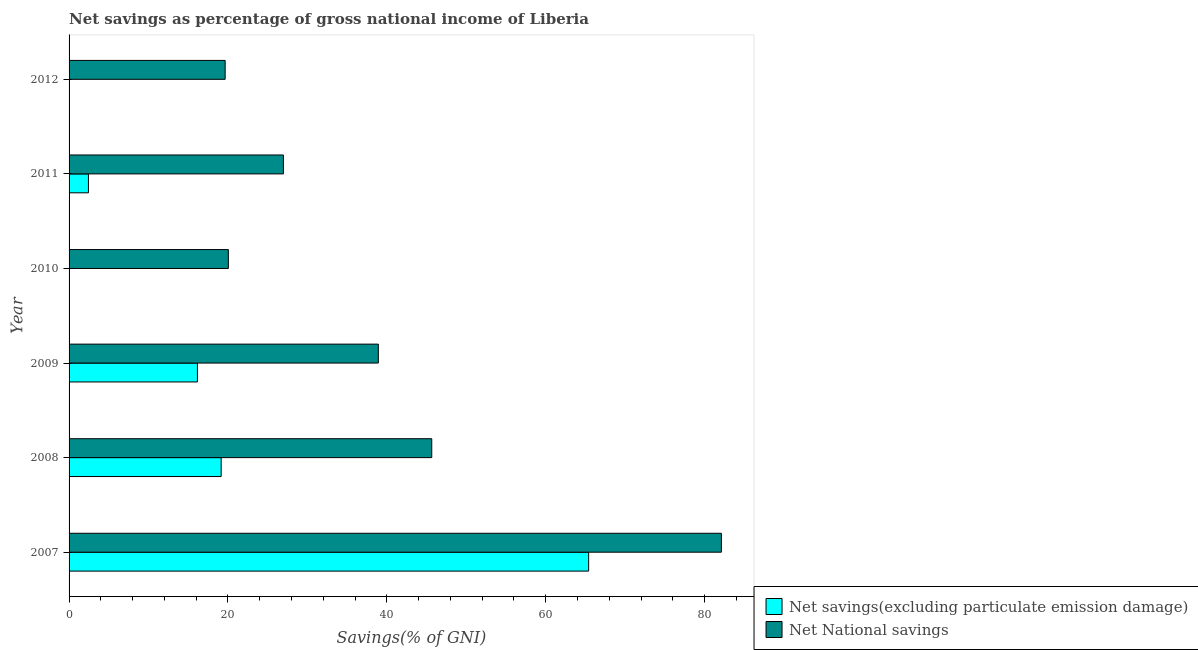Are the number of bars per tick equal to the number of legend labels?
Offer a terse response. No. Are the number of bars on each tick of the Y-axis equal?
Offer a very short reply. No. What is the label of the 2nd group of bars from the top?
Offer a terse response. 2011. What is the net national savings in 2010?
Ensure brevity in your answer.  20.05. Across all years, what is the maximum net national savings?
Your answer should be compact. 82.12. In which year was the net national savings maximum?
Ensure brevity in your answer.  2007. What is the total net national savings in the graph?
Your answer should be compact. 233.39. What is the difference between the net national savings in 2008 and that in 2009?
Your answer should be compact. 6.73. What is the difference between the net national savings in 2012 and the net savings(excluding particulate emission damage) in 2008?
Keep it short and to the point. 0.5. What is the average net savings(excluding particulate emission damage) per year?
Give a very brief answer. 17.19. In the year 2008, what is the difference between the net national savings and net savings(excluding particulate emission damage)?
Your answer should be compact. 26.51. What is the ratio of the net national savings in 2007 to that in 2010?
Your answer should be compact. 4.1. Is the net national savings in 2011 less than that in 2012?
Offer a very short reply. No. What is the difference between the highest and the second highest net national savings?
Keep it short and to the point. 36.46. What is the difference between the highest and the lowest net national savings?
Your answer should be compact. 62.47. Is the sum of the net savings(excluding particulate emission damage) in 2008 and 2011 greater than the maximum net national savings across all years?
Ensure brevity in your answer.  No. Are all the bars in the graph horizontal?
Give a very brief answer. Yes. How many years are there in the graph?
Ensure brevity in your answer.  6. Does the graph contain grids?
Your answer should be compact. No. Where does the legend appear in the graph?
Offer a terse response. Bottom right. What is the title of the graph?
Ensure brevity in your answer.  Net savings as percentage of gross national income of Liberia. Does "Arms exports" appear as one of the legend labels in the graph?
Provide a short and direct response. No. What is the label or title of the X-axis?
Offer a terse response. Savings(% of GNI). What is the Savings(% of GNI) in Net savings(excluding particulate emission damage) in 2007?
Your answer should be very brief. 65.41. What is the Savings(% of GNI) in Net National savings in 2007?
Your answer should be very brief. 82.12. What is the Savings(% of GNI) of Net savings(excluding particulate emission damage) in 2008?
Keep it short and to the point. 19.15. What is the Savings(% of GNI) in Net National savings in 2008?
Keep it short and to the point. 45.66. What is the Savings(% of GNI) in Net savings(excluding particulate emission damage) in 2009?
Your answer should be compact. 16.16. What is the Savings(% of GNI) of Net National savings in 2009?
Offer a very short reply. 38.93. What is the Savings(% of GNI) in Net savings(excluding particulate emission damage) in 2010?
Offer a terse response. 0. What is the Savings(% of GNI) in Net National savings in 2010?
Your answer should be compact. 20.05. What is the Savings(% of GNI) in Net savings(excluding particulate emission damage) in 2011?
Offer a very short reply. 2.44. What is the Savings(% of GNI) in Net National savings in 2011?
Give a very brief answer. 26.98. What is the Savings(% of GNI) of Net savings(excluding particulate emission damage) in 2012?
Offer a terse response. 0. What is the Savings(% of GNI) in Net National savings in 2012?
Ensure brevity in your answer.  19.65. Across all years, what is the maximum Savings(% of GNI) in Net savings(excluding particulate emission damage)?
Offer a very short reply. 65.41. Across all years, what is the maximum Savings(% of GNI) in Net National savings?
Offer a terse response. 82.12. Across all years, what is the minimum Savings(% of GNI) in Net National savings?
Ensure brevity in your answer.  19.65. What is the total Savings(% of GNI) in Net savings(excluding particulate emission damage) in the graph?
Your response must be concise. 103.15. What is the total Savings(% of GNI) of Net National savings in the graph?
Offer a very short reply. 233.39. What is the difference between the Savings(% of GNI) of Net savings(excluding particulate emission damage) in 2007 and that in 2008?
Your answer should be compact. 46.26. What is the difference between the Savings(% of GNI) of Net National savings in 2007 and that in 2008?
Provide a short and direct response. 36.46. What is the difference between the Savings(% of GNI) of Net savings(excluding particulate emission damage) in 2007 and that in 2009?
Provide a succinct answer. 49.25. What is the difference between the Savings(% of GNI) in Net National savings in 2007 and that in 2009?
Your response must be concise. 43.19. What is the difference between the Savings(% of GNI) of Net National savings in 2007 and that in 2010?
Your answer should be very brief. 62.07. What is the difference between the Savings(% of GNI) of Net savings(excluding particulate emission damage) in 2007 and that in 2011?
Provide a succinct answer. 62.97. What is the difference between the Savings(% of GNI) in Net National savings in 2007 and that in 2011?
Your answer should be very brief. 55.14. What is the difference between the Savings(% of GNI) in Net National savings in 2007 and that in 2012?
Provide a short and direct response. 62.47. What is the difference between the Savings(% of GNI) of Net savings(excluding particulate emission damage) in 2008 and that in 2009?
Give a very brief answer. 2.99. What is the difference between the Savings(% of GNI) of Net National savings in 2008 and that in 2009?
Offer a very short reply. 6.73. What is the difference between the Savings(% of GNI) in Net National savings in 2008 and that in 2010?
Offer a very short reply. 25.61. What is the difference between the Savings(% of GNI) of Net savings(excluding particulate emission damage) in 2008 and that in 2011?
Offer a very short reply. 16.71. What is the difference between the Savings(% of GNI) in Net National savings in 2008 and that in 2011?
Offer a very short reply. 18.68. What is the difference between the Savings(% of GNI) in Net National savings in 2008 and that in 2012?
Provide a succinct answer. 26.01. What is the difference between the Savings(% of GNI) in Net National savings in 2009 and that in 2010?
Your answer should be very brief. 18.88. What is the difference between the Savings(% of GNI) in Net savings(excluding particulate emission damage) in 2009 and that in 2011?
Your answer should be compact. 13.72. What is the difference between the Savings(% of GNI) of Net National savings in 2009 and that in 2011?
Provide a short and direct response. 11.95. What is the difference between the Savings(% of GNI) of Net National savings in 2009 and that in 2012?
Give a very brief answer. 19.28. What is the difference between the Savings(% of GNI) in Net National savings in 2010 and that in 2011?
Provide a succinct answer. -6.93. What is the difference between the Savings(% of GNI) of Net National savings in 2010 and that in 2012?
Your response must be concise. 0.4. What is the difference between the Savings(% of GNI) of Net National savings in 2011 and that in 2012?
Keep it short and to the point. 7.33. What is the difference between the Savings(% of GNI) of Net savings(excluding particulate emission damage) in 2007 and the Savings(% of GNI) of Net National savings in 2008?
Your answer should be very brief. 19.75. What is the difference between the Savings(% of GNI) of Net savings(excluding particulate emission damage) in 2007 and the Savings(% of GNI) of Net National savings in 2009?
Keep it short and to the point. 26.48. What is the difference between the Savings(% of GNI) in Net savings(excluding particulate emission damage) in 2007 and the Savings(% of GNI) in Net National savings in 2010?
Provide a short and direct response. 45.36. What is the difference between the Savings(% of GNI) in Net savings(excluding particulate emission damage) in 2007 and the Savings(% of GNI) in Net National savings in 2011?
Ensure brevity in your answer.  38.43. What is the difference between the Savings(% of GNI) of Net savings(excluding particulate emission damage) in 2007 and the Savings(% of GNI) of Net National savings in 2012?
Keep it short and to the point. 45.76. What is the difference between the Savings(% of GNI) in Net savings(excluding particulate emission damage) in 2008 and the Savings(% of GNI) in Net National savings in 2009?
Provide a succinct answer. -19.79. What is the difference between the Savings(% of GNI) in Net savings(excluding particulate emission damage) in 2008 and the Savings(% of GNI) in Net National savings in 2010?
Provide a succinct answer. -0.9. What is the difference between the Savings(% of GNI) in Net savings(excluding particulate emission damage) in 2008 and the Savings(% of GNI) in Net National savings in 2011?
Keep it short and to the point. -7.83. What is the difference between the Savings(% of GNI) of Net savings(excluding particulate emission damage) in 2008 and the Savings(% of GNI) of Net National savings in 2012?
Provide a short and direct response. -0.5. What is the difference between the Savings(% of GNI) in Net savings(excluding particulate emission damage) in 2009 and the Savings(% of GNI) in Net National savings in 2010?
Offer a terse response. -3.89. What is the difference between the Savings(% of GNI) in Net savings(excluding particulate emission damage) in 2009 and the Savings(% of GNI) in Net National savings in 2011?
Keep it short and to the point. -10.82. What is the difference between the Savings(% of GNI) in Net savings(excluding particulate emission damage) in 2009 and the Savings(% of GNI) in Net National savings in 2012?
Offer a terse response. -3.49. What is the difference between the Savings(% of GNI) of Net savings(excluding particulate emission damage) in 2011 and the Savings(% of GNI) of Net National savings in 2012?
Keep it short and to the point. -17.21. What is the average Savings(% of GNI) in Net savings(excluding particulate emission damage) per year?
Your response must be concise. 17.19. What is the average Savings(% of GNI) of Net National savings per year?
Offer a terse response. 38.9. In the year 2007, what is the difference between the Savings(% of GNI) of Net savings(excluding particulate emission damage) and Savings(% of GNI) of Net National savings?
Offer a very short reply. -16.71. In the year 2008, what is the difference between the Savings(% of GNI) in Net savings(excluding particulate emission damage) and Savings(% of GNI) in Net National savings?
Give a very brief answer. -26.51. In the year 2009, what is the difference between the Savings(% of GNI) in Net savings(excluding particulate emission damage) and Savings(% of GNI) in Net National savings?
Make the answer very short. -22.77. In the year 2011, what is the difference between the Savings(% of GNI) of Net savings(excluding particulate emission damage) and Savings(% of GNI) of Net National savings?
Your answer should be compact. -24.54. What is the ratio of the Savings(% of GNI) in Net savings(excluding particulate emission damage) in 2007 to that in 2008?
Ensure brevity in your answer.  3.42. What is the ratio of the Savings(% of GNI) of Net National savings in 2007 to that in 2008?
Ensure brevity in your answer.  1.8. What is the ratio of the Savings(% of GNI) in Net savings(excluding particulate emission damage) in 2007 to that in 2009?
Offer a terse response. 4.05. What is the ratio of the Savings(% of GNI) of Net National savings in 2007 to that in 2009?
Ensure brevity in your answer.  2.11. What is the ratio of the Savings(% of GNI) in Net National savings in 2007 to that in 2010?
Provide a short and direct response. 4.1. What is the ratio of the Savings(% of GNI) in Net savings(excluding particulate emission damage) in 2007 to that in 2011?
Make the answer very short. 26.82. What is the ratio of the Savings(% of GNI) of Net National savings in 2007 to that in 2011?
Give a very brief answer. 3.04. What is the ratio of the Savings(% of GNI) of Net National savings in 2007 to that in 2012?
Give a very brief answer. 4.18. What is the ratio of the Savings(% of GNI) in Net savings(excluding particulate emission damage) in 2008 to that in 2009?
Provide a short and direct response. 1.18. What is the ratio of the Savings(% of GNI) in Net National savings in 2008 to that in 2009?
Your answer should be very brief. 1.17. What is the ratio of the Savings(% of GNI) of Net National savings in 2008 to that in 2010?
Ensure brevity in your answer.  2.28. What is the ratio of the Savings(% of GNI) of Net savings(excluding particulate emission damage) in 2008 to that in 2011?
Make the answer very short. 7.85. What is the ratio of the Savings(% of GNI) in Net National savings in 2008 to that in 2011?
Your answer should be very brief. 1.69. What is the ratio of the Savings(% of GNI) of Net National savings in 2008 to that in 2012?
Your response must be concise. 2.32. What is the ratio of the Savings(% of GNI) in Net National savings in 2009 to that in 2010?
Give a very brief answer. 1.94. What is the ratio of the Savings(% of GNI) in Net savings(excluding particulate emission damage) in 2009 to that in 2011?
Your answer should be very brief. 6.63. What is the ratio of the Savings(% of GNI) of Net National savings in 2009 to that in 2011?
Provide a short and direct response. 1.44. What is the ratio of the Savings(% of GNI) of Net National savings in 2009 to that in 2012?
Make the answer very short. 1.98. What is the ratio of the Savings(% of GNI) of Net National savings in 2010 to that in 2011?
Your answer should be very brief. 0.74. What is the ratio of the Savings(% of GNI) of Net National savings in 2010 to that in 2012?
Offer a very short reply. 1.02. What is the ratio of the Savings(% of GNI) in Net National savings in 2011 to that in 2012?
Offer a terse response. 1.37. What is the difference between the highest and the second highest Savings(% of GNI) of Net savings(excluding particulate emission damage)?
Your answer should be very brief. 46.26. What is the difference between the highest and the second highest Savings(% of GNI) of Net National savings?
Offer a terse response. 36.46. What is the difference between the highest and the lowest Savings(% of GNI) of Net savings(excluding particulate emission damage)?
Make the answer very short. 65.41. What is the difference between the highest and the lowest Savings(% of GNI) of Net National savings?
Provide a succinct answer. 62.47. 